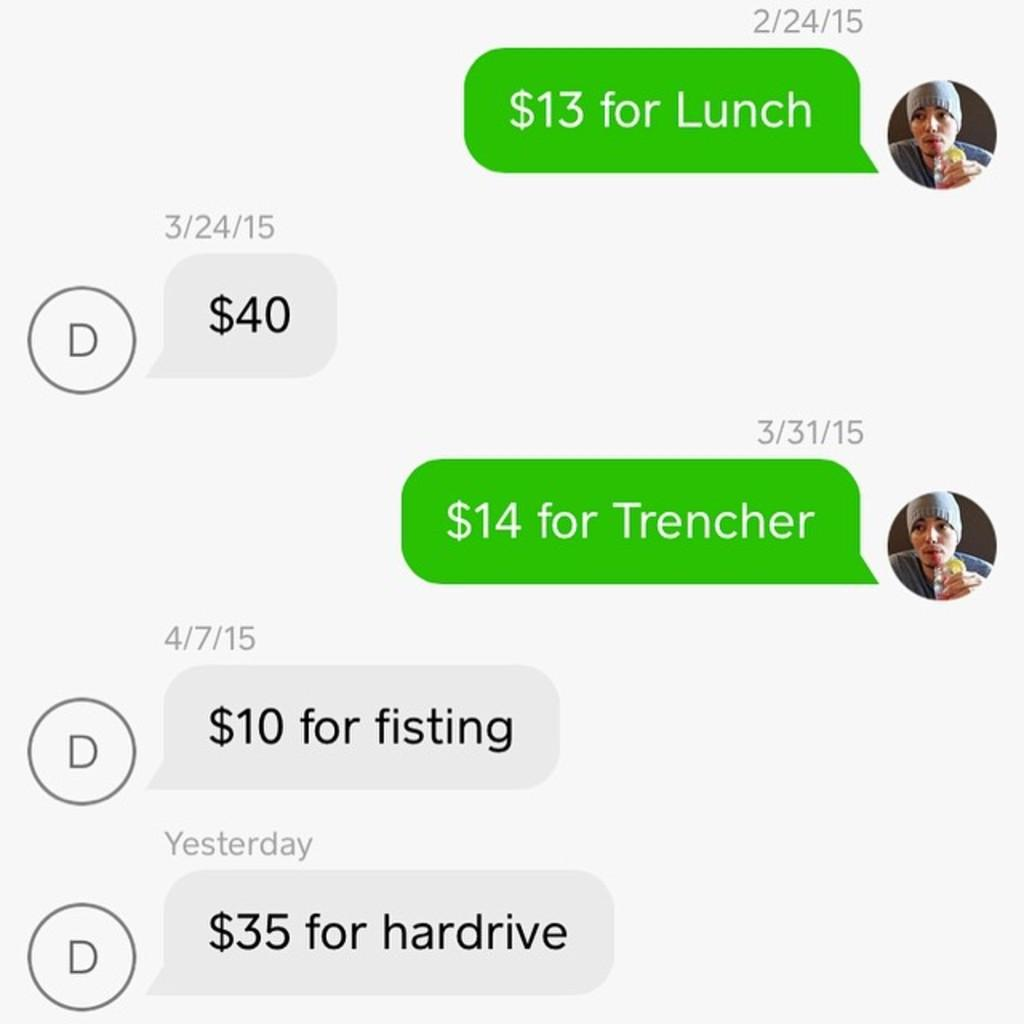What type of content is displayed in the image? The image contains a screenshot of a conversation. What type of family activity is shown in the image? There is no family activity shown in the image, as it contains a screenshot of a conversation. What type of cabbage is being used to cover the conversation in the image? There is no cabbage present in the image, and the conversation is not being covered by any object. 